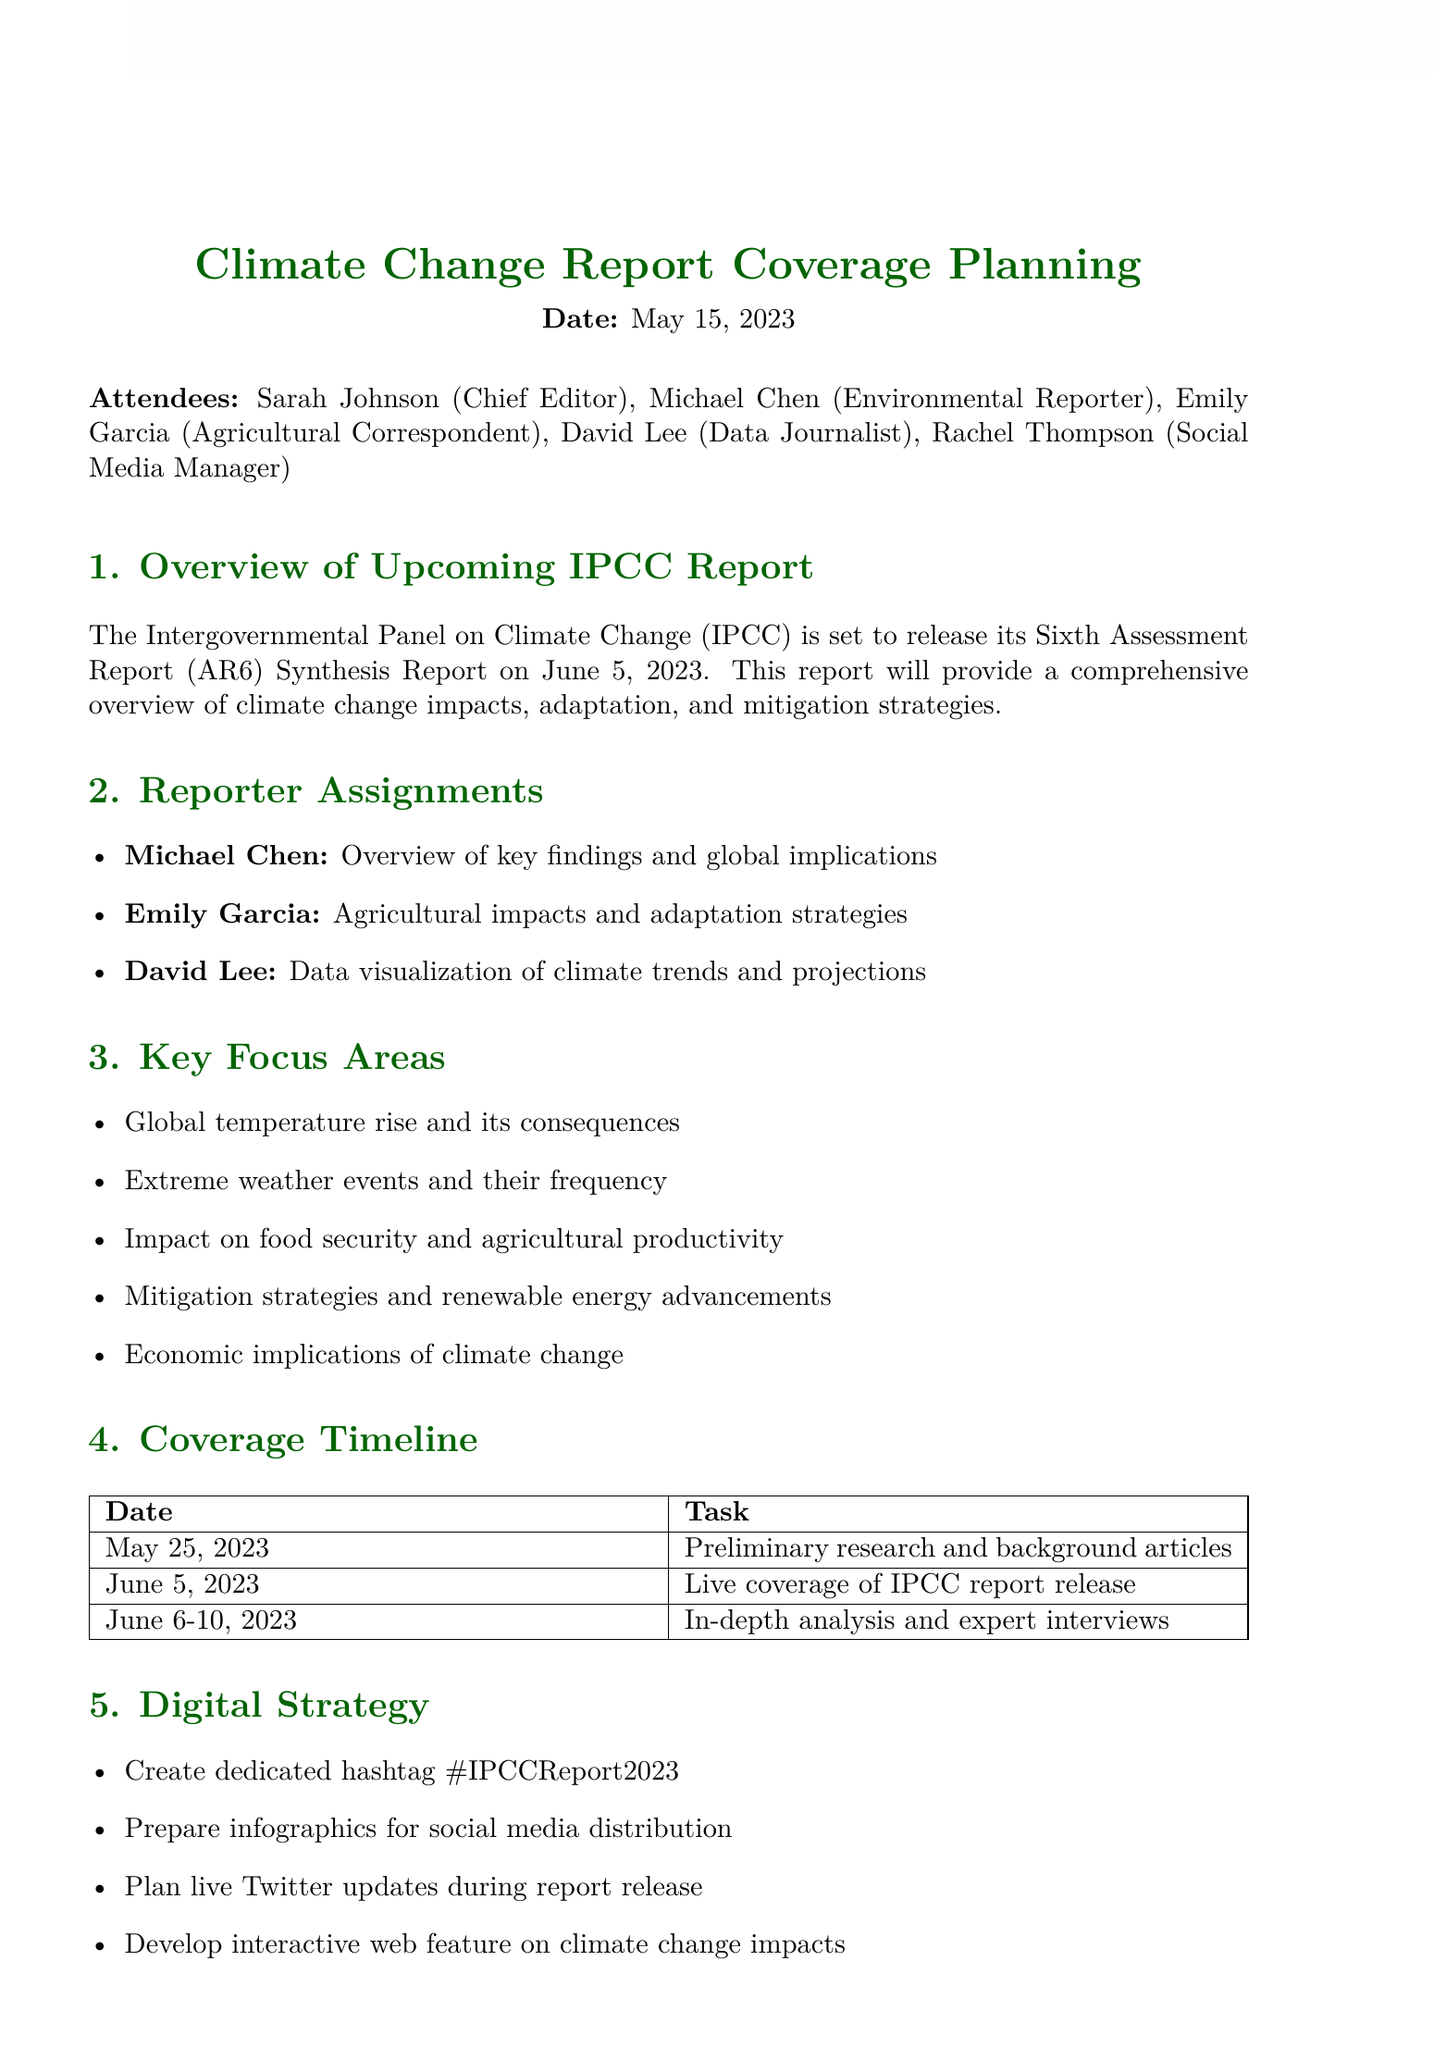What is the date of the meeting? The date of the meeting is clearly stated at the beginning of the document.
Answer: May 15, 2023 Who is the Chief Editor? The document lists attendees, including their roles, and identifies the Chief Editor.
Answer: Sarah Johnson What is the focus area related to agriculture? The document outlines key focus areas and specifically mentions one that pertains to agriculture.
Answer: Impact on food security and agricultural productivity When is the IPCC report scheduled for release? The overview section mentions the release date of the IPCC report.
Answer: June 5, 2023 What task is due by May 25, 2023? The coverage timeline section lists specific tasks and their due dates, including one that falls on May 25.
Answer: Preliminary research and background articles Who is assigned to data visualization? The reporter assignments specify which reporter is responsible for data visualization.
Answer: David Lee What hashtag will be created for social media? The digital strategy section mentions a dedicated hashtag for the coverage.
Answer: #IPCCReport2023 What action is Rachel responsible for? The action items outline specific tasks assigned to team members, including Rachel's responsibility.
Answer: Coordinate with IT for web feature development 